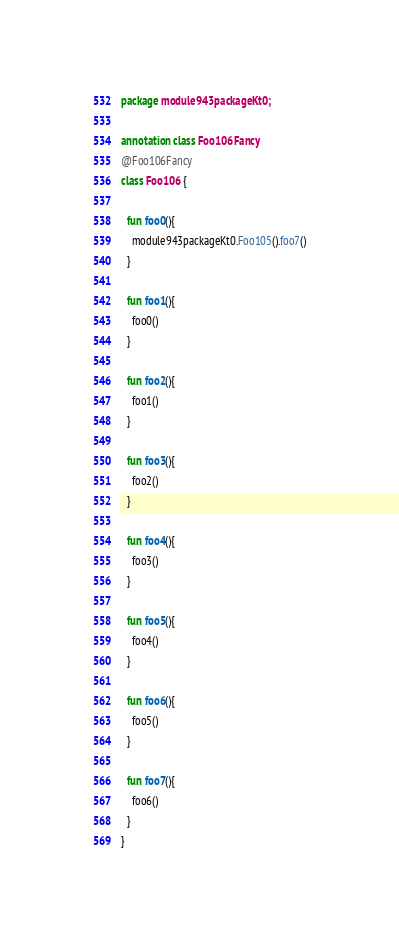<code> <loc_0><loc_0><loc_500><loc_500><_Kotlin_>package module943packageKt0;

annotation class Foo106Fancy
@Foo106Fancy
class Foo106 {

  fun foo0(){
    module943packageKt0.Foo105().foo7()
  }

  fun foo1(){
    foo0()
  }

  fun foo2(){
    foo1()
  }

  fun foo3(){
    foo2()
  }

  fun foo4(){
    foo3()
  }

  fun foo5(){
    foo4()
  }

  fun foo6(){
    foo5()
  }

  fun foo7(){
    foo6()
  }
}</code> 